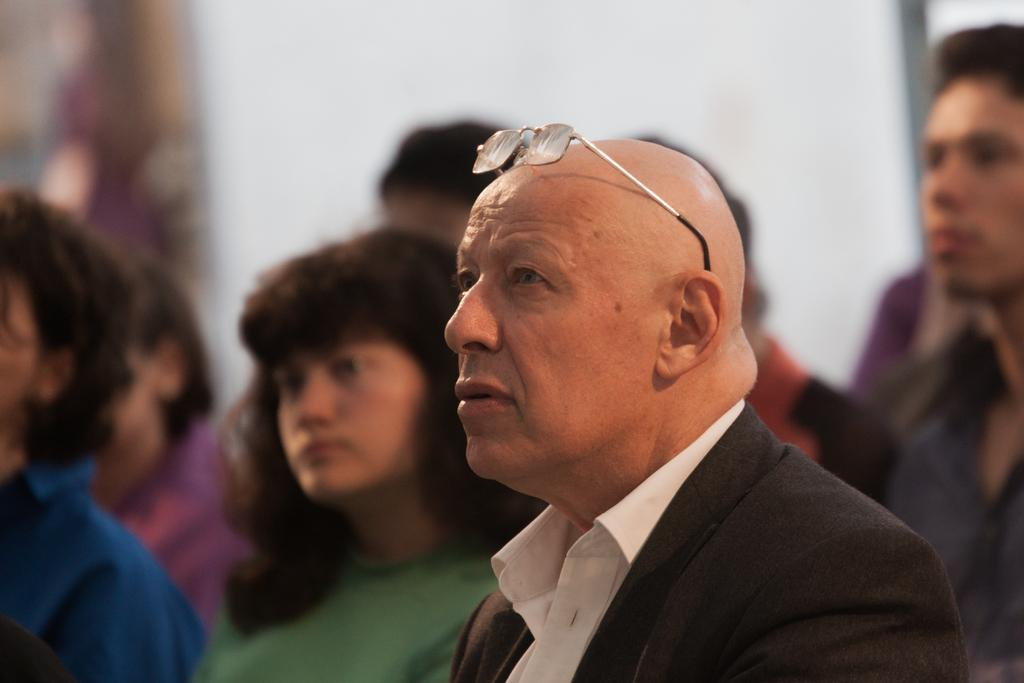How many people are in the image? There are a few people in the image. Can you describe the background of the image? The background of the image is blurred. What type of insurance policy is being discussed by the people in the image? There is no indication in the image that the people are discussing any insurance policies. 